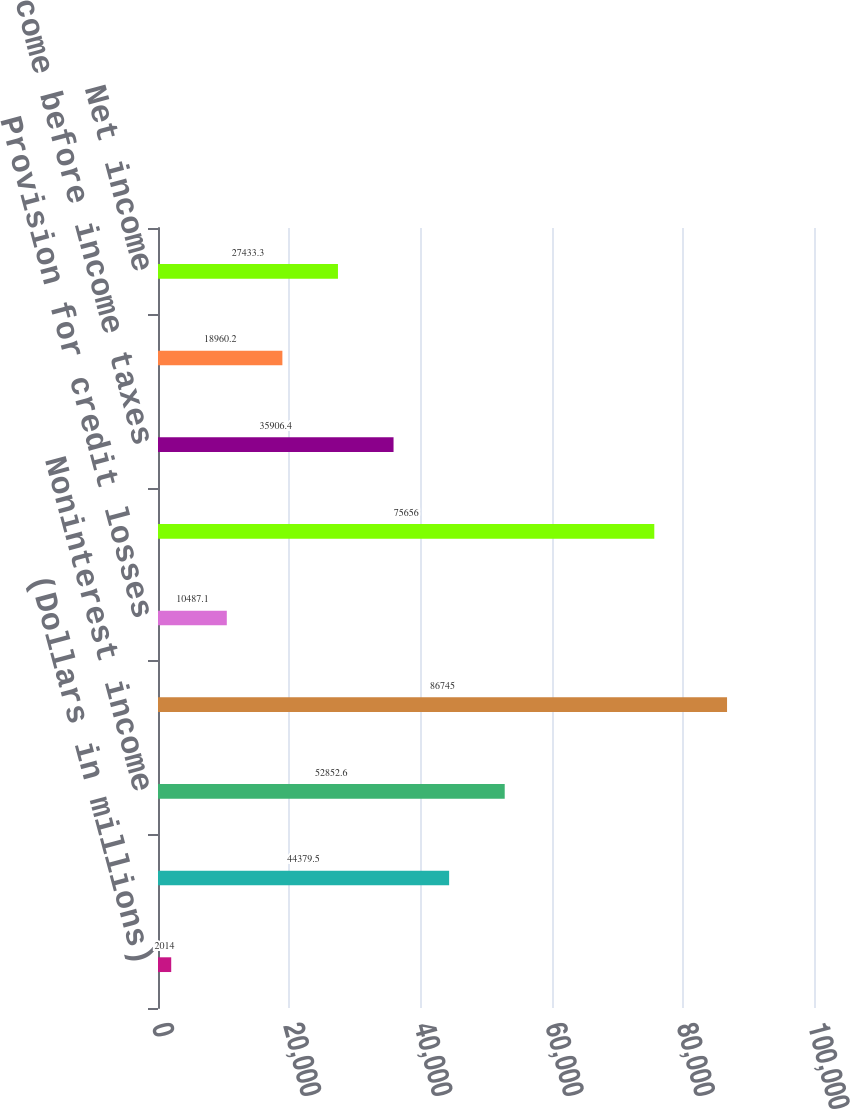<chart> <loc_0><loc_0><loc_500><loc_500><bar_chart><fcel>(Dollars in millions)<fcel>Net interest income (FTE<fcel>Noninterest income<fcel>Total revenue net of interest<fcel>Provision for credit losses<fcel>Noninterest expense<fcel>Income before income taxes<fcel>Income tax expense (FTE basis)<fcel>Net income<nl><fcel>2014<fcel>44379.5<fcel>52852.6<fcel>86745<fcel>10487.1<fcel>75656<fcel>35906.4<fcel>18960.2<fcel>27433.3<nl></chart> 